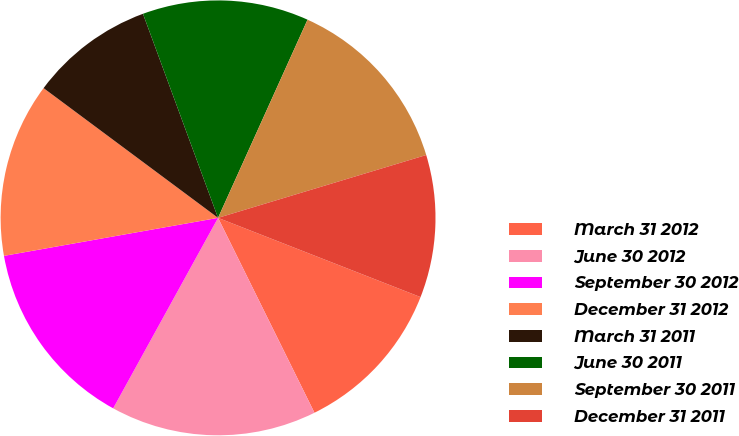Convert chart to OTSL. <chart><loc_0><loc_0><loc_500><loc_500><pie_chart><fcel>March 31 2012<fcel>June 30 2012<fcel>September 30 2012<fcel>December 31 2012<fcel>March 31 2011<fcel>June 30 2011<fcel>September 30 2011<fcel>December 31 2011<nl><fcel>11.75%<fcel>15.32%<fcel>14.19%<fcel>12.97%<fcel>9.21%<fcel>12.36%<fcel>13.58%<fcel>10.6%<nl></chart> 